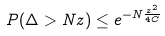Convert formula to latex. <formula><loc_0><loc_0><loc_500><loc_500>P ( \Delta > N z ) \leq e ^ { - N \frac { z ^ { 2 } } { 4 C } }</formula> 